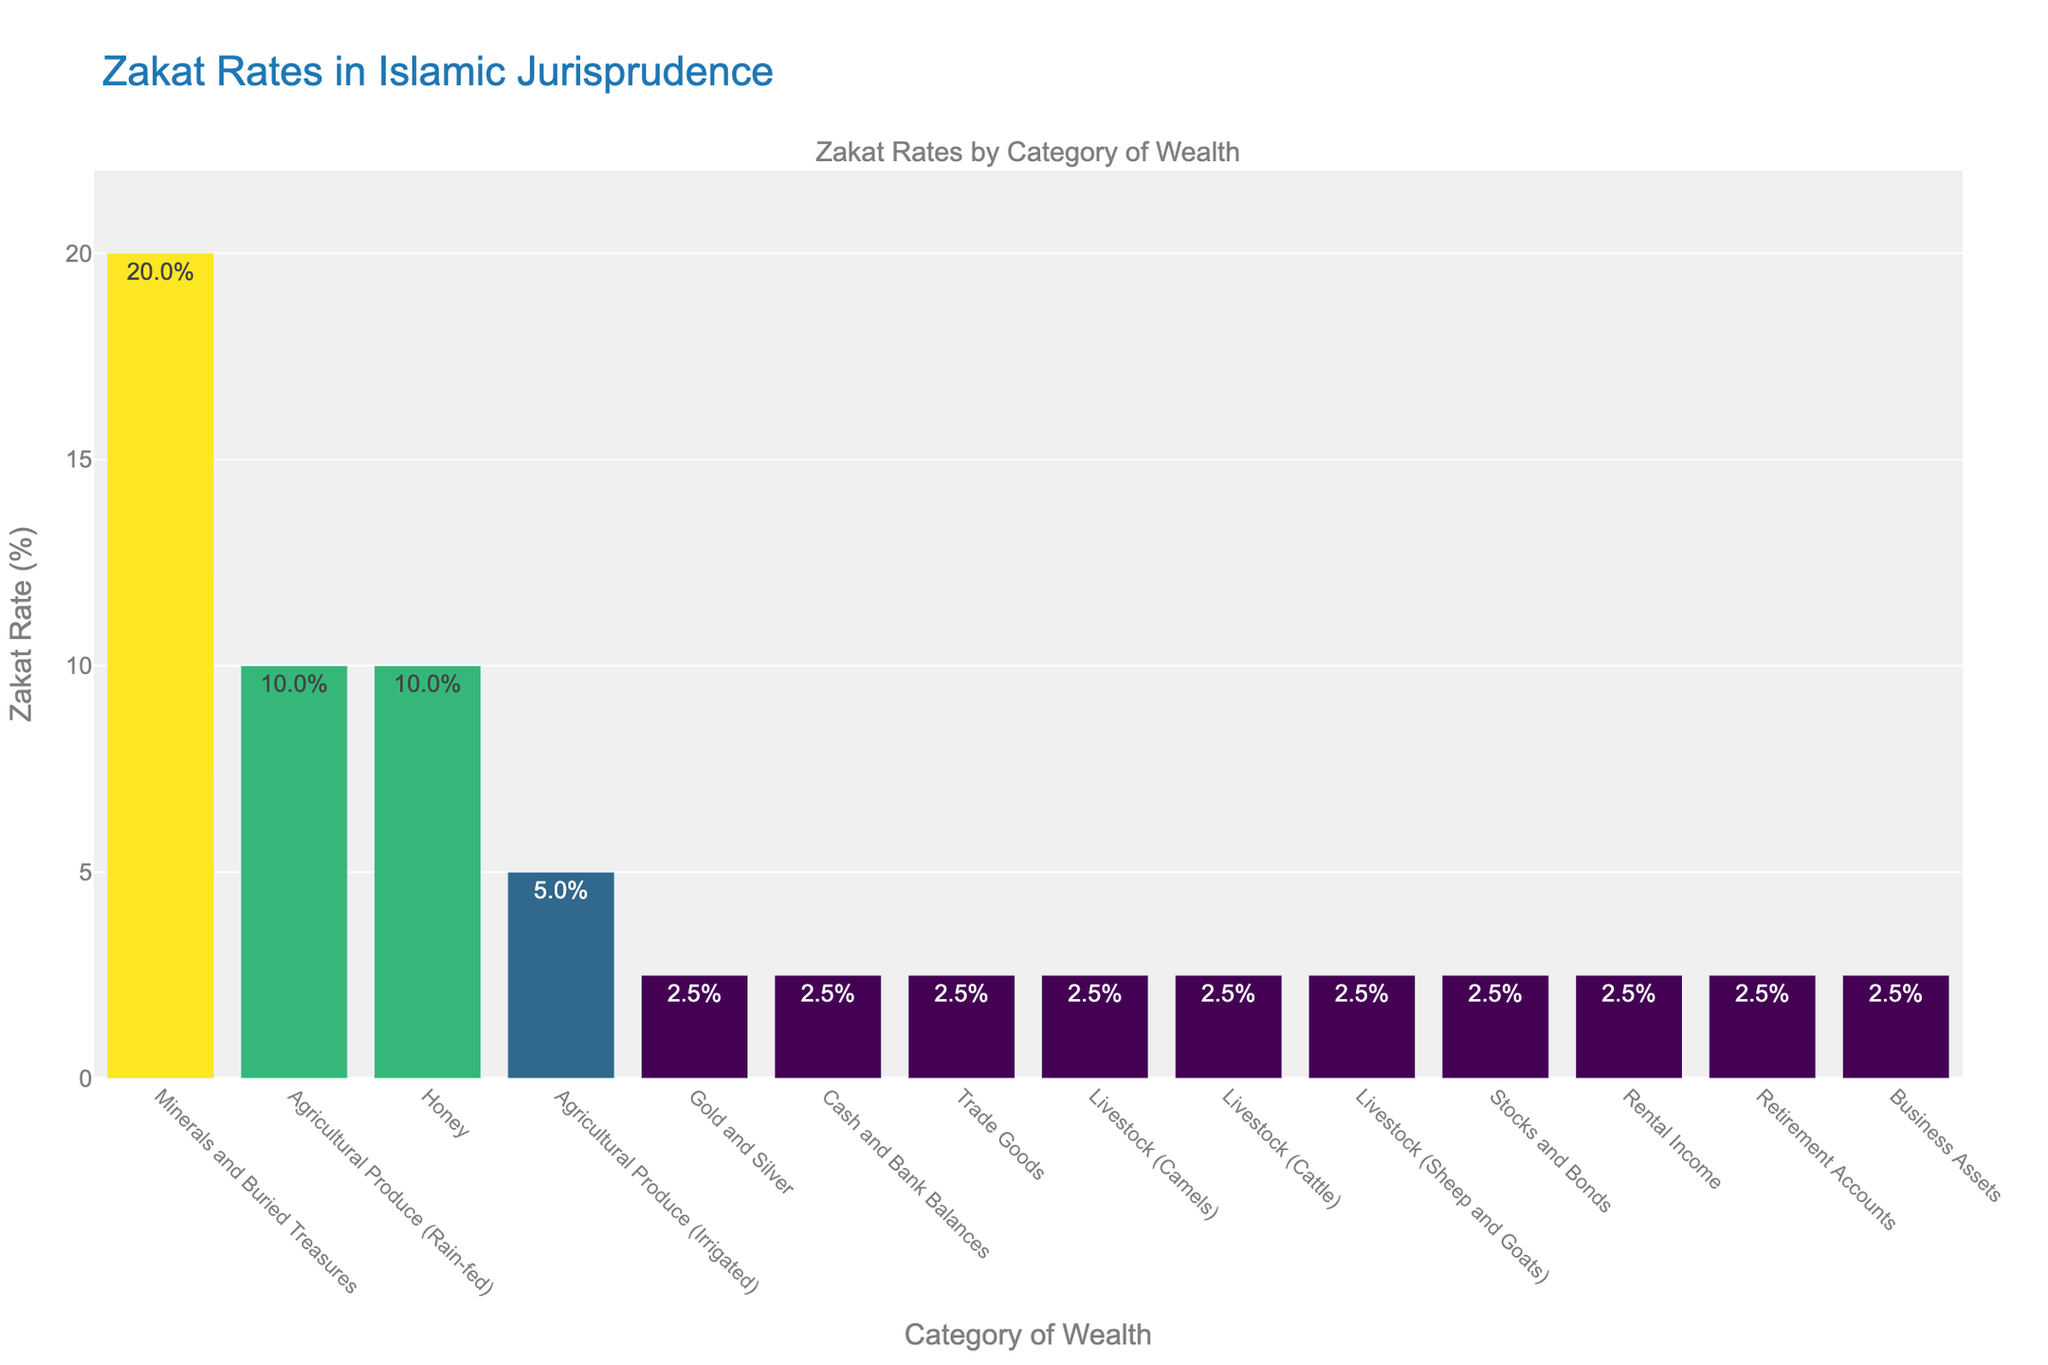What's the Zakat rate for minerals and buried treasures? The bar labeled "Minerals and Buried Treasures" shows a Zakat rate of 20%, which is indicated by the height of the bar and the text displayed.
Answer: 20% Which category has the highest Zakat rate? The tallest bar in the visualization corresponds to "Minerals and Buried Treasures," indicating it has the highest Zakat rate.
Answer: Minerals and Buried Treasures Are the Zakat rates for gold and silver, cash and bank balances, and trade goods the same? All these categories have bars of equal height, each displaying a Zakat rate of 2.5%, indicating they have the same rate.
Answer: Yes What is the difference in Zakat rates between rain-fed agricultural produce and irrigated agricultural produce? The bar for rain-fed agricultural produce shows a Zakat rate of 10%, while the bar for irrigated agricultural produce shows a rate of 5%. The difference is 10% - 5% = 5%.
Answer: 5% Which categories have a Zakat rate of 2.5%? The bars labeled "Gold and Silver," "Cash and Bank Balances," "Trade Goods," "Livestock (Camels)," "Livestock (Cattle)," "Livestock (Sheep and Goats)," "Stocks and Bonds," "Rental Income," "Retirement Accounts," and "Business Assets" all display a Zakat rate of 2.5%.
Answer: Gold and Silver, Cash and Bank Balances, Trade Goods, Livestock (Camels), Livestock (Cattle), Livestock (Sheep and Goats), Stocks and Bonds, Rental Income, Retirement Accounts, Business Assets How much higher is the Zakat rate for honey compared to trade goods? The bar for honey shows a Zakat rate of 10%, while the bar for trade goods shows a rate of 2.5%. The difference is 10% - 2.5% = 7.5%.
Answer: 7.5% What is the average Zakat rate for all the categories? Sum all Zakat rates (2.5 + 2.5 + 2.5 + 2.5 + 2.5 + 2.5 + 5 + 10 + 10 + 20 + 2.5 + 2.5 + 2.5 + 2.5) = 72.5, then divide by the number of categories (14). The average rate is 72.5 / 14 ≈ 5.18%.
Answer: ≈ 5.18% If you exclude the category with the highest Zakat rate, what is the new average rate? First, exclude the highest rate, 20%. Sum the remaining rates (2.5 + 2.5 + 2.5 + 2.5 + 2.5 + 2.5 + 5 + 10 + 10 + 2.5 + 2.5 + 2.5 + 2.5) = 52.5. Then, divide by the new number of categories (13). The new average rate is 52.5 / 13 ≈ 4.04%.
Answer: ≈ 4.04% How many categories have a Zakat rate greater than or equal to 10%? The bars for "Agricultural Produce (Rain-fed)," "Honey," and "Minerals and Buried Treasures" show Zakat rates of 10% or higher. There are 3 such categories.
Answer: 3 Which categories fall under the Zakat rate range of 5% to 10%? The bars for "Agricultural Produce (Irrigated)" and "Agricultural Produce (Rain-fed)" show Zakat rates within the range of 5% to 10%.
Answer: Agricultural Produce (Irrigated), Agricultural Produce (Rain-fed) 